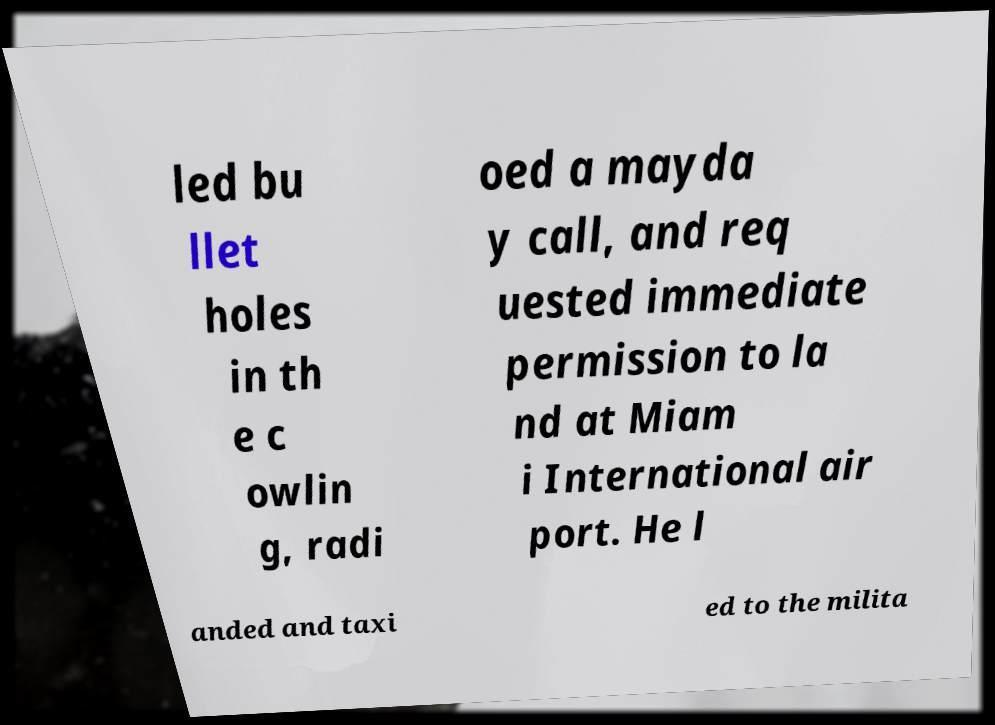Can you read and provide the text displayed in the image?This photo seems to have some interesting text. Can you extract and type it out for me? led bu llet holes in th e c owlin g, radi oed a mayda y call, and req uested immediate permission to la nd at Miam i International air port. He l anded and taxi ed to the milita 